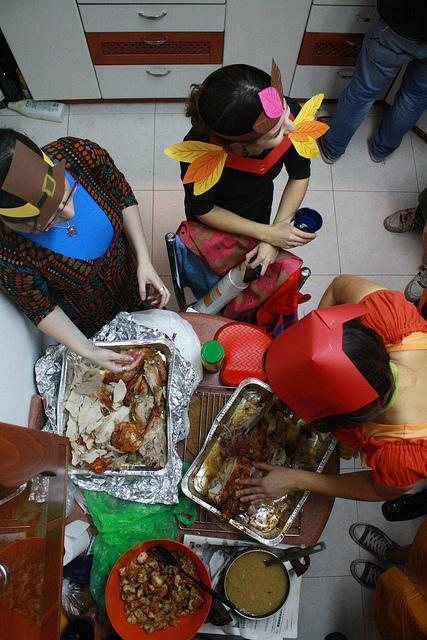What holiday do the people seem to be celebrating?

Choices:
A) labor day
B) christmas
C) easter
D) thanksgiving thanksgiving 